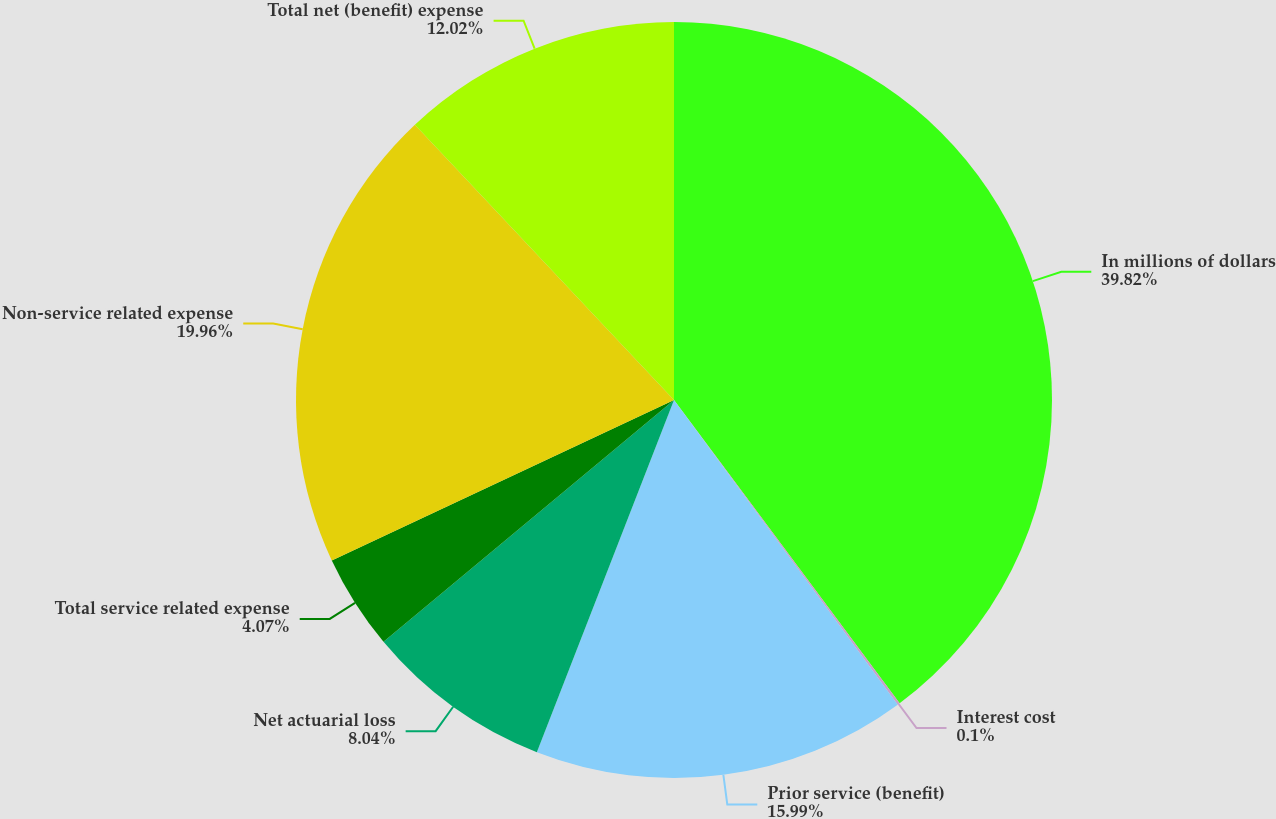Convert chart to OTSL. <chart><loc_0><loc_0><loc_500><loc_500><pie_chart><fcel>In millions of dollars<fcel>Interest cost<fcel>Prior service (benefit)<fcel>Net actuarial loss<fcel>Total service related expense<fcel>Non-service related expense<fcel>Total net (benefit) expense<nl><fcel>39.82%<fcel>0.1%<fcel>15.99%<fcel>8.04%<fcel>4.07%<fcel>19.96%<fcel>12.02%<nl></chart> 